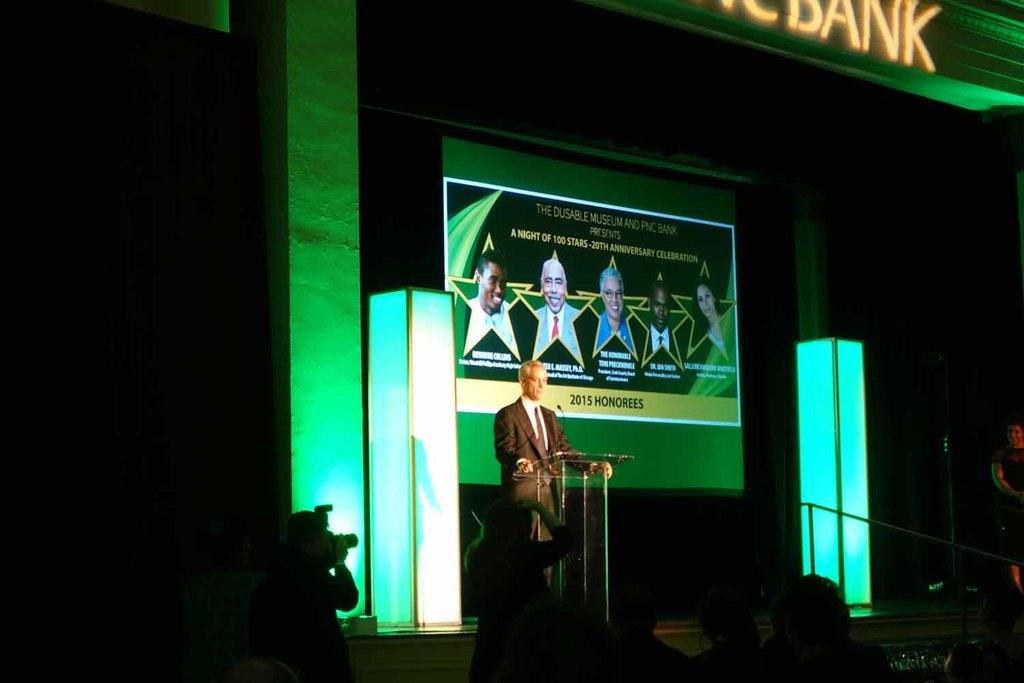What is the man standing in the image doing? There is a man standing in the image, but his actions are not specified. What object is present in the image that is typically used for amplifying sound? There is a microphone in the image. What can be seen on the screen in the image? There is a screen with people on it in the image. How many people are present in the scene? There are people present in the scene, but the exact number is not specified. What type of comb is the achiever using in the image? There is no achiever or comb present in the image. What type of lace is draped over the microphone in the image? There is no lace present in the image. 